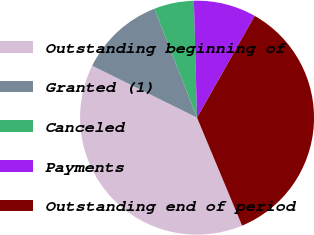Convert chart to OTSL. <chart><loc_0><loc_0><loc_500><loc_500><pie_chart><fcel>Outstanding beginning of<fcel>Granted (1)<fcel>Canceled<fcel>Payments<fcel>Outstanding end of period<nl><fcel>38.61%<fcel>11.74%<fcel>5.51%<fcel>8.63%<fcel>35.5%<nl></chart> 